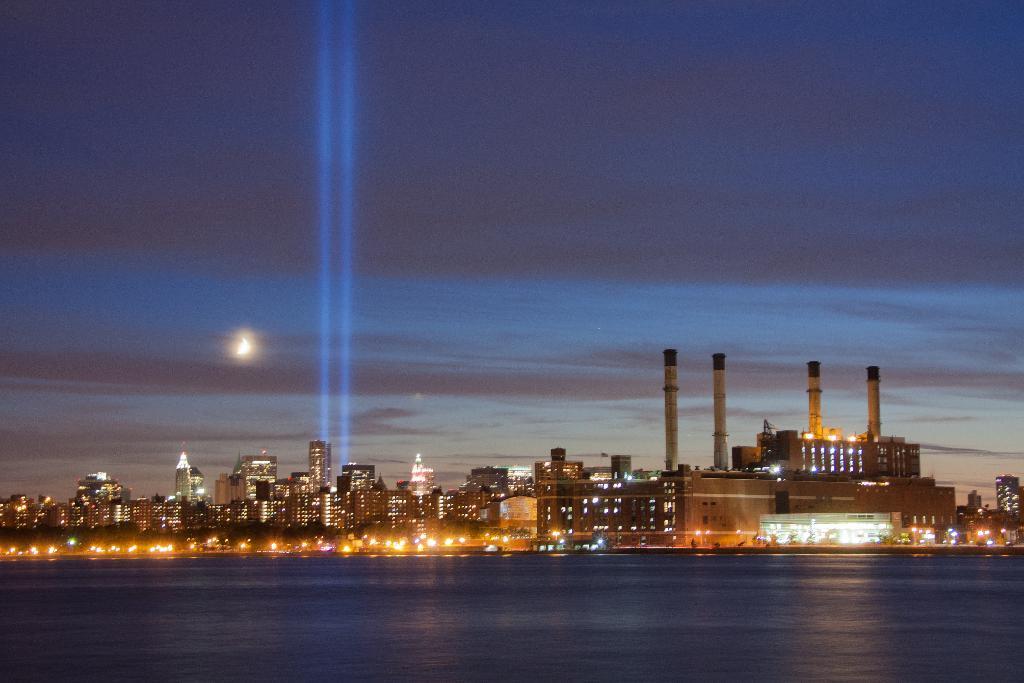Please provide a concise description of this image. The image is captured in the night time, it is a beautiful city and it has many houses, buildings and tall towers. The city is very colorful with bright lights and in front of the city there is a sea. 